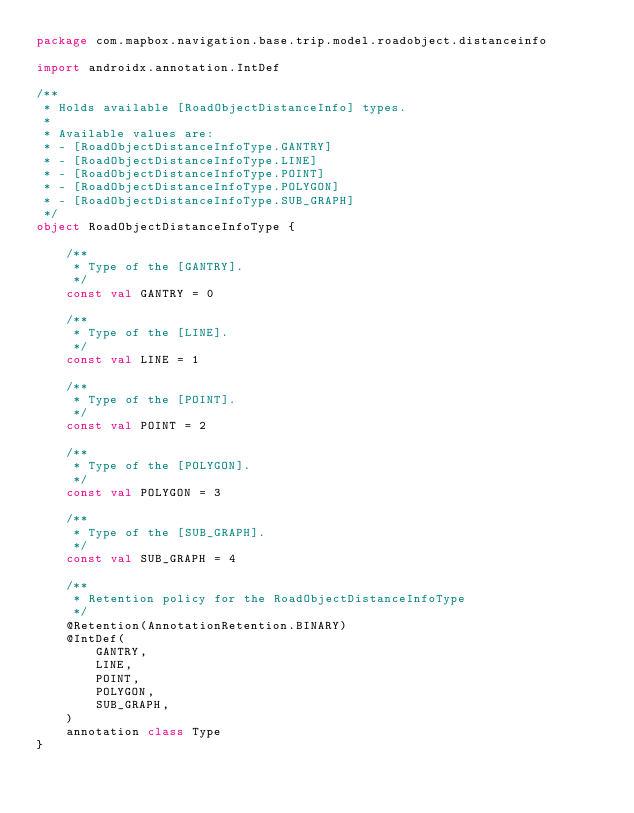Convert code to text. <code><loc_0><loc_0><loc_500><loc_500><_Kotlin_>package com.mapbox.navigation.base.trip.model.roadobject.distanceinfo

import androidx.annotation.IntDef

/**
 * Holds available [RoadObjectDistanceInfo] types.
 *
 * Available values are:
 * - [RoadObjectDistanceInfoType.GANTRY]
 * - [RoadObjectDistanceInfoType.LINE]
 * - [RoadObjectDistanceInfoType.POINT]
 * - [RoadObjectDistanceInfoType.POLYGON]
 * - [RoadObjectDistanceInfoType.SUB_GRAPH]
 */
object RoadObjectDistanceInfoType {

    /**
     * Type of the [GANTRY].
     */
    const val GANTRY = 0

    /**
     * Type of the [LINE].
     */
    const val LINE = 1

    /**
     * Type of the [POINT].
     */
    const val POINT = 2

    /**
     * Type of the [POLYGON].
     */
    const val POLYGON = 3

    /**
     * Type of the [SUB_GRAPH].
     */
    const val SUB_GRAPH = 4

    /**
     * Retention policy for the RoadObjectDistanceInfoType
     */
    @Retention(AnnotationRetention.BINARY)
    @IntDef(
        GANTRY,
        LINE,
        POINT,
        POLYGON,
        SUB_GRAPH,
    )
    annotation class Type
}
</code> 